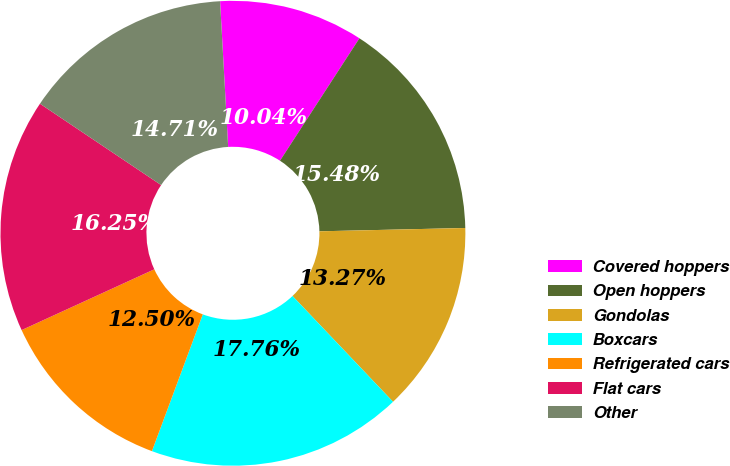Convert chart. <chart><loc_0><loc_0><loc_500><loc_500><pie_chart><fcel>Covered hoppers<fcel>Open hoppers<fcel>Gondolas<fcel>Boxcars<fcel>Refrigerated cars<fcel>Flat cars<fcel>Other<nl><fcel>10.04%<fcel>15.48%<fcel>13.27%<fcel>17.76%<fcel>12.5%<fcel>16.25%<fcel>14.71%<nl></chart> 